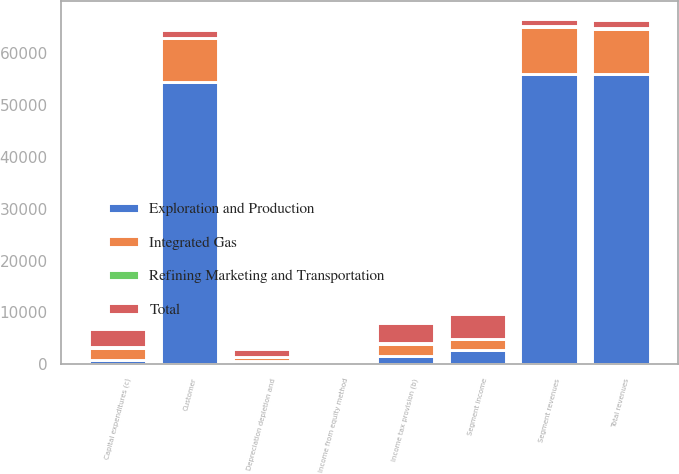Convert chart to OTSL. <chart><loc_0><loc_0><loc_500><loc_500><stacked_bar_chart><ecel><fcel>Customer<fcel>Segment revenues<fcel>Total revenues<fcel>Segment income<fcel>Income from equity method<fcel>Depreciation depletion and<fcel>Income tax provision (b)<fcel>Capital expenditures (c)<nl><fcel>Integrated Gas<fcel>8326<fcel>9010<fcel>8792<fcel>2003<fcel>206<fcel>919<fcel>2371<fcel>2169<nl><fcel>Exploration and Production<fcel>54471<fcel>55941<fcel>55925<fcel>2795<fcel>145<fcel>558<fcel>1642<fcel>916<nl><fcel>Refining Marketing and Transportation<fcel>179<fcel>179<fcel>179<fcel>16<fcel>40<fcel>9<fcel>8<fcel>307<nl><fcel>Total<fcel>1486<fcel>1486<fcel>1486<fcel>4814<fcel>391<fcel>1486<fcel>4021<fcel>3392<nl></chart> 